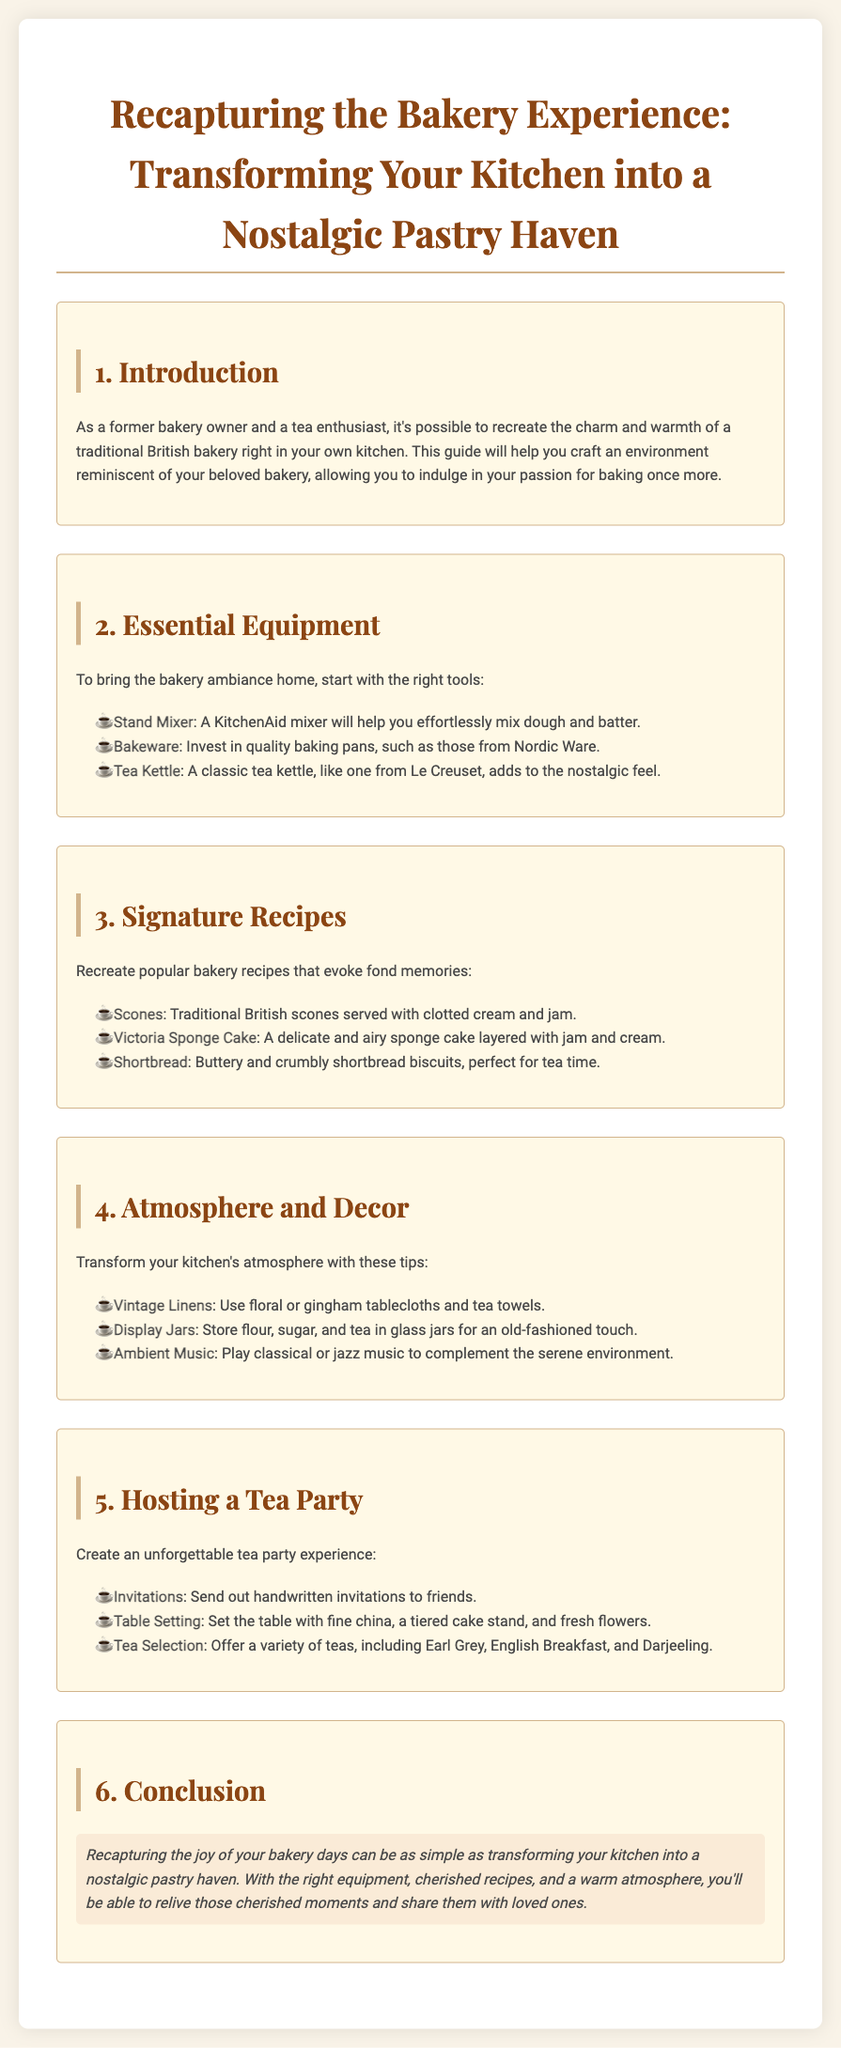What is the title of the guide? The title of the guide is provided at the top of the document.
Answer: Recapturing the Bakery Experience: Transforming Your Kitchen into a Nostalgic Pastry Haven What equipment is recommended for baking? The document lists essential equipment needed for transforming a kitchen into a bakery.
Answer: Stand Mixer, Bakeware, Tea Kettle How many signature recipes are mentioned? The number of signature recipes listed in the 'Signature Recipes' section is specified in the document.
Answer: 3 What type of music is suggested for the atmosphere? The document suggests a type of music to complement the emotional ambiance of the kitchen.
Answer: Classical or jazz music What are two types of tea recommended for a tea party? The guide mentions specific teas that can be served at a tea party.
Answer: Earl Grey, English Breakfast What is a suggested table setting item for a tea party? The document provides details on how to set the table for a tea party.
Answer: Fine china What feeling does the guide aim to evoke? The overall theme and goal of the guide is indicated throughout the text.
Answer: Nostalgic pastry haven How is the conclusion section styled? The conclusion section contains a specific styling element to emphasize its importance.
Answer: Highlighted background 